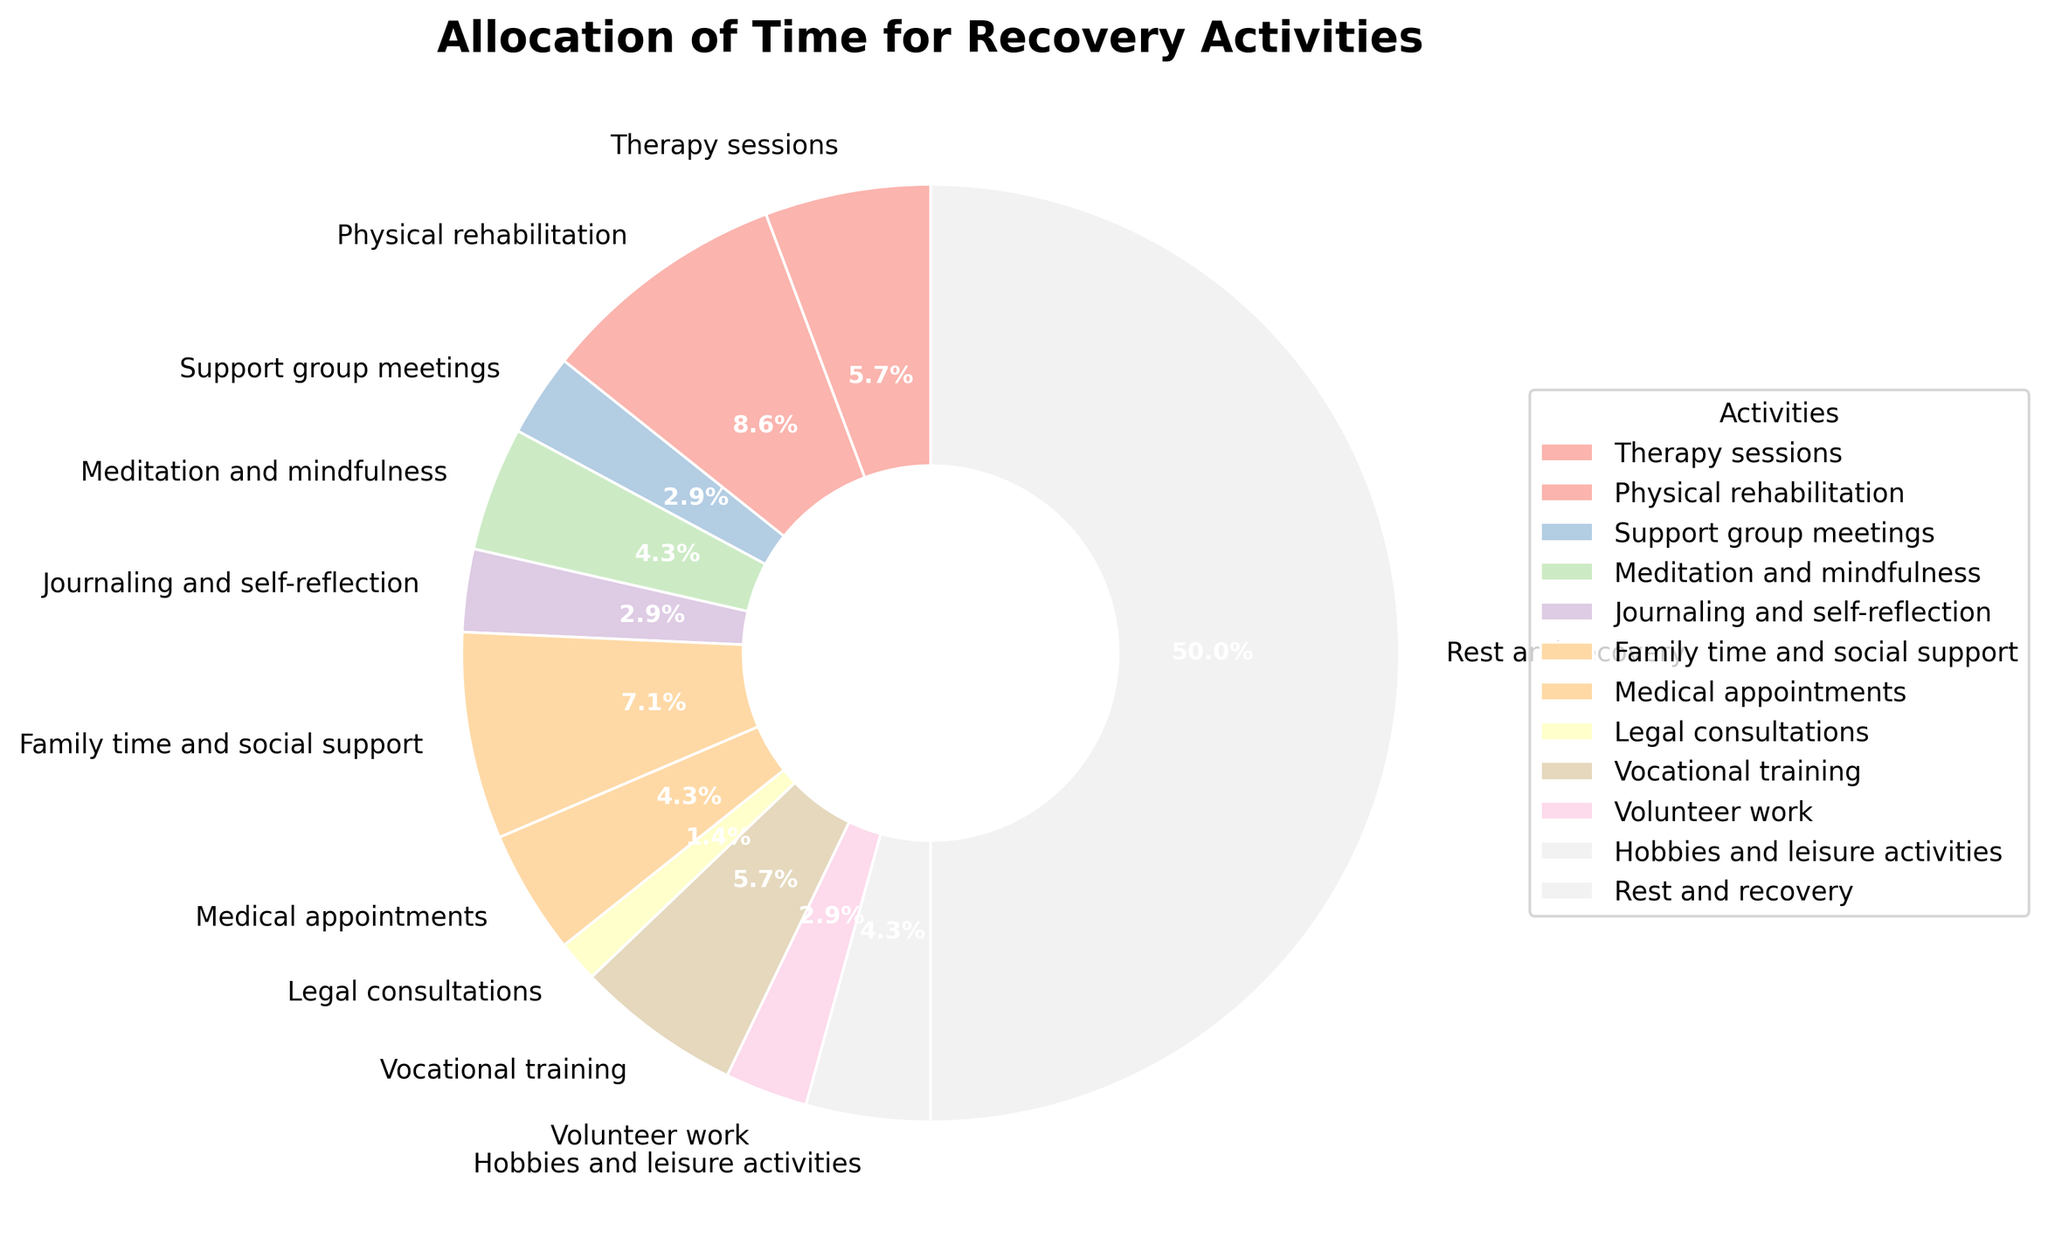What activity takes up the most time each week? By examining the chart, the "Rest and recovery" segment occupies the largest portion of the pie chart, indicating it takes up the most time.
Answer: Rest and recovery How many hours per week are dedicated to therapy sessions and physical rehabilitation combined? According to the chart, therapy sessions account for 4 hours and physical rehabilitation accounts for 6 hours per week. Adding these two values together gives 4 + 6 = 10 hours.
Answer: 10 hours Which activity takes less time: medical appointments or vocational training? Comparing the sizes of the pie chart segments, "Medical appointments" take 3 hours, and "Vocational training" takes 4 hours per week. Thus, medical appointments take less time.
Answer: Medical appointments What percentage of the weekly hours is spent on hobbies and leisure activities? The chart shows that "Hobbies and leisure activities" make up 3 hours out of the total weekly hours. Calculating the percentage: (3 / 70) * 100 = 4.3%.
Answer: 4.3% How much more time is spent on family time and social support compared to support group meetings? "Family time and social support" is allocated 5 hours per week, while "Support group meetings" is allocated 2 hours. The difference is 5 - 2 = 3 hours more.
Answer: 3 hours more What fraction of the total recovery time is spent on legal consultations? Legal consultations make up 1 hour of the total 70 recovery hours per week. Thus, the fraction is 1/70.
Answer: 1/70 Which activities are allocated equal time each week? The activities "Support group meetings" and "Journaling and self-reflection" both have segments that correspond to 2 hours each week.
Answer: Support group meetings and Journaling and self-reflection What activities together account for approximately one-third of the total weekly hours? Adding up the hours for "Rest and recovery" (35 hours) and "Therapy sessions" (4 hours) gives 39 hours. Since the total weekly hours are 70, 39/70 is approximately 0.557, which is slightly over one-third but very close.
Answer: Rest and recovery and Therapy sessions 